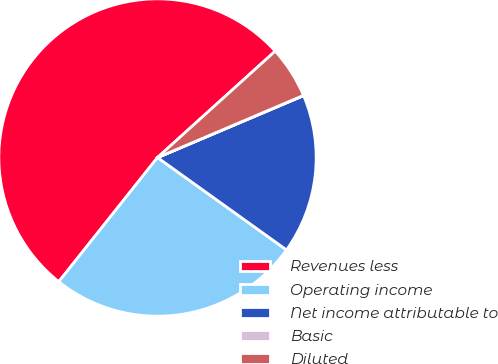Convert chart. <chart><loc_0><loc_0><loc_500><loc_500><pie_chart><fcel>Revenues less<fcel>Operating income<fcel>Net income attributable to<fcel>Basic<fcel>Diluted<nl><fcel>52.61%<fcel>25.8%<fcel>16.27%<fcel>0.03%<fcel>5.29%<nl></chart> 